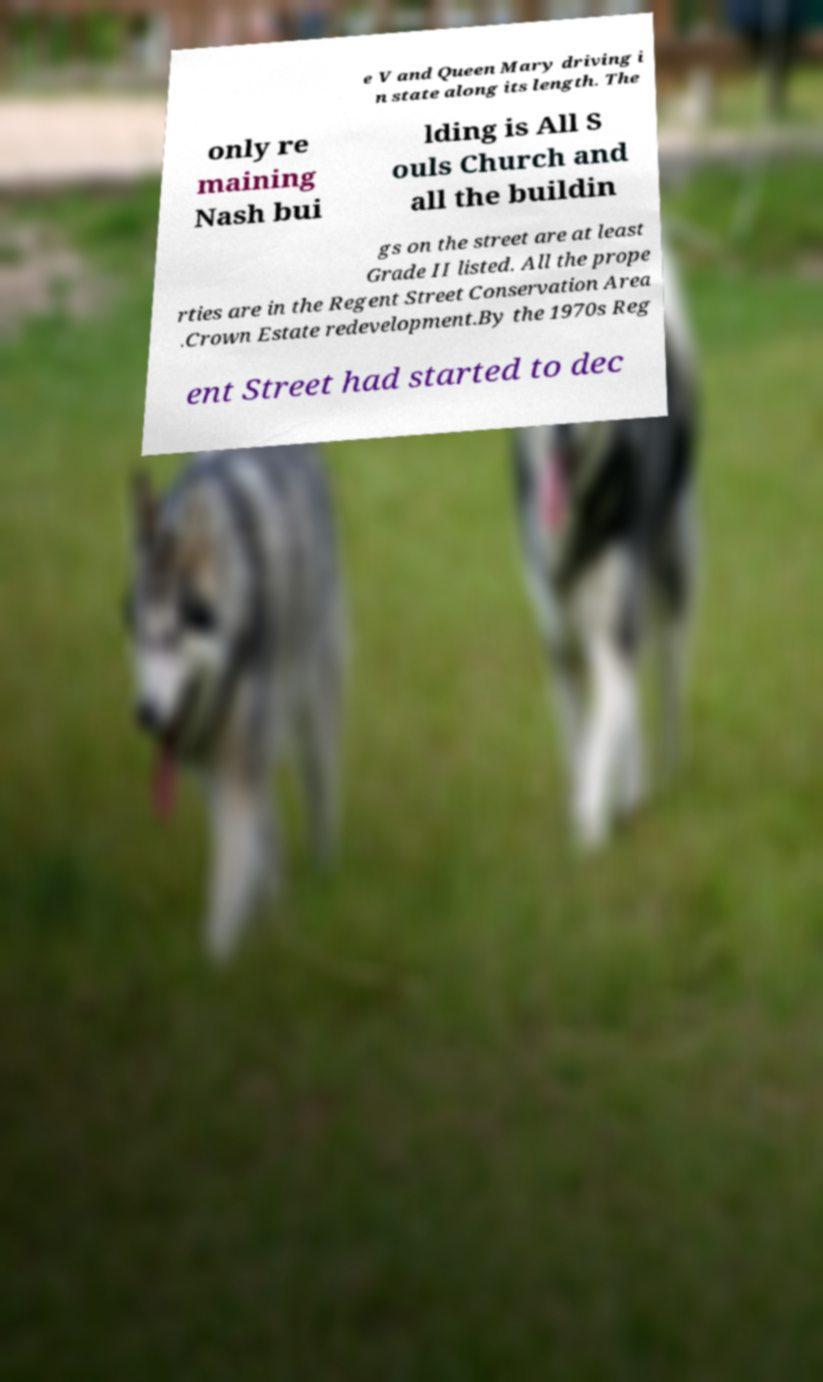For documentation purposes, I need the text within this image transcribed. Could you provide that? e V and Queen Mary driving i n state along its length. The only re maining Nash bui lding is All S ouls Church and all the buildin gs on the street are at least Grade II listed. All the prope rties are in the Regent Street Conservation Area .Crown Estate redevelopment.By the 1970s Reg ent Street had started to dec 